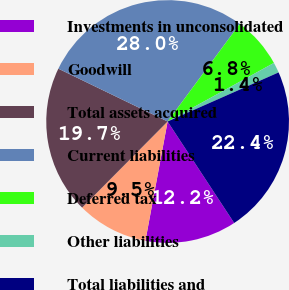Convert chart. <chart><loc_0><loc_0><loc_500><loc_500><pie_chart><fcel>Investments in unconsolidated<fcel>Goodwill<fcel>Total assets acquired<fcel>Current liabilities<fcel>Deferred tax<fcel>Other liabilities<fcel>Total liabilities and<nl><fcel>12.17%<fcel>9.51%<fcel>19.73%<fcel>27.97%<fcel>6.85%<fcel>1.39%<fcel>22.39%<nl></chart> 